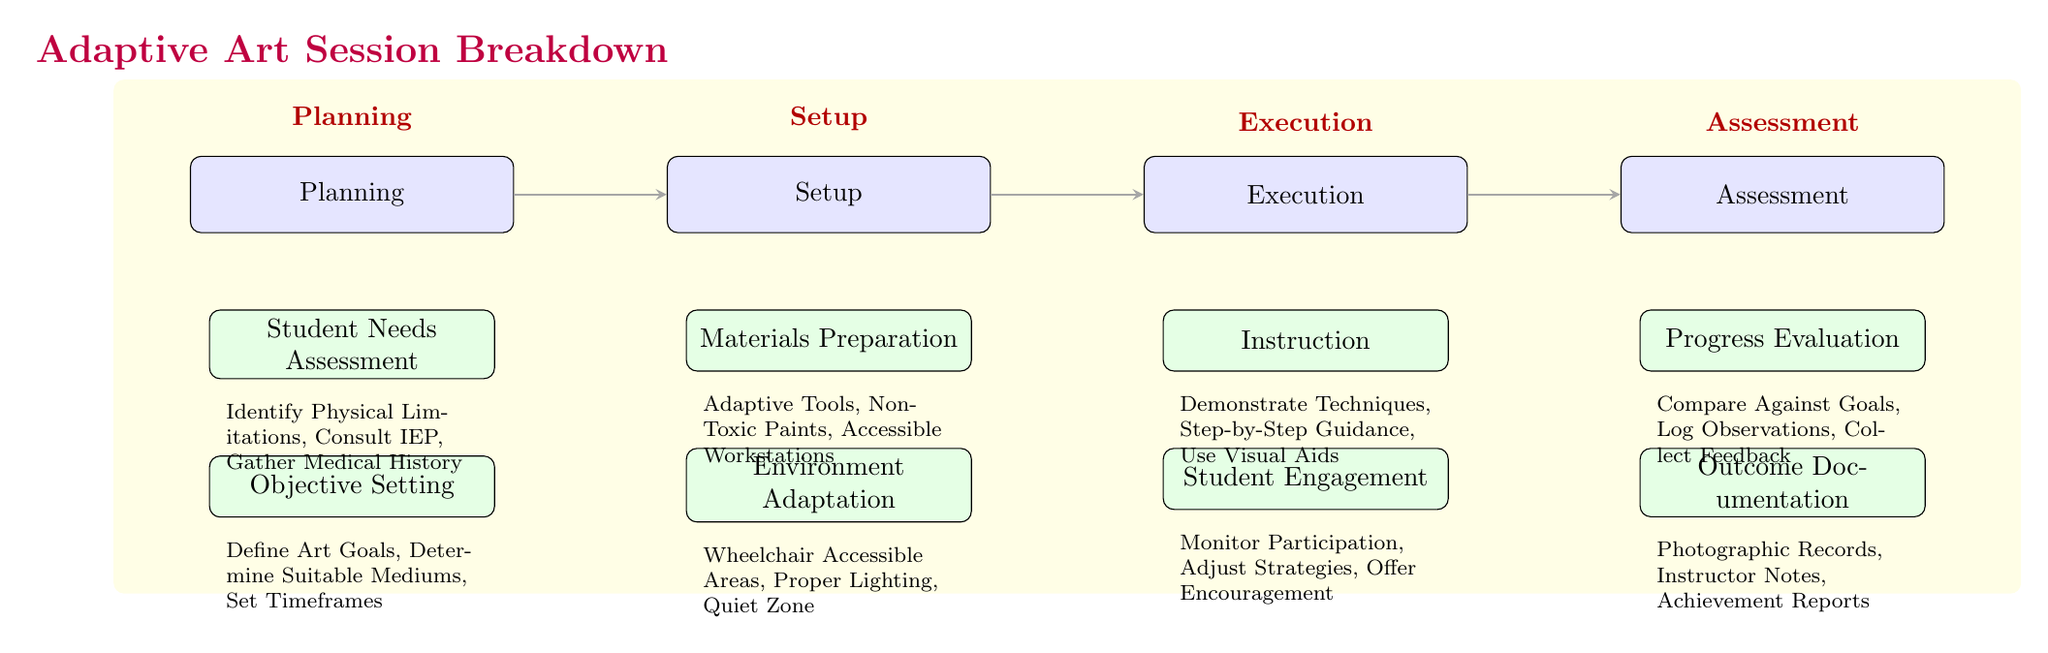What is the first stage of the adaptive art session? The first stage in the diagram is labeled "Planning." It appears at the far left and initiates the flow of the session breakdown.
Answer: Planning How many subsections are there under the Setup stage? The Setup stage has two subsections listed below it: "Materials Preparation" and "Environment Adaptation." Counting these gives us a total of two subsections.
Answer: 2 Which subsection under Execution addresses student interaction? The subsection that focuses on student interaction is "Student Engagement." It is positioned below the "Instruction" subsection within the Execution stage.
Answer: Student Engagement What are the three components listed in the Student Needs Assessment? The components listed are "Identify Physical Limitations," "Consult IEP," and "Gather Medical History." These are identified under the Planning stage.
Answer: Identify Physical Limitations, Consult IEP, Gather Medical History What is the role of the evaluation stage in the adaptive art session? The evaluation stage involves "Compare Against Goals," "Log Observations," and "Collect Feedback." This helps assess the progress made during the session, ensuring that outcomes can be documented accurately.
Answer: Compare Against Goals, Log Observations, Collect Feedback Which section does the arrow lead to from the Setup stage? The diagram shows an arrow leading from the Setup stage to the Execution stage, indicating the progression from preparation to implementation.
Answer: Execution How is the environment adapted according to the diagram? The diagram specifies "Wheelchair Accessible Areas," "Proper Lighting," and "Quiet Zone" as adaptations made to the environment. This shows the focus on making the space suitable for all students.
Answer: Wheelchair Accessible Areas, Proper Lighting, Quiet Zone What is located above the Planning section in the diagram? Above the Planning section is the title "Adaptive Art Session Breakdown," which provides the overall context of the diagram.
Answer: Adaptive Art Session Breakdown How many main stages are outlined in the adaptive art session? The diagram outlines four main stages: Planning, Setup, Execution, and Assessment. This is easily counted by identifying the major boxes at the top of the flow.
Answer: 4 